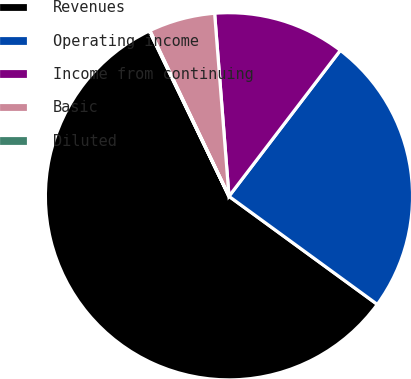Convert chart. <chart><loc_0><loc_0><loc_500><loc_500><pie_chart><fcel>Revenues<fcel>Operating income<fcel>Income from continuing<fcel>Basic<fcel>Diluted<nl><fcel>57.83%<fcel>24.65%<fcel>11.62%<fcel>5.84%<fcel>0.06%<nl></chart> 